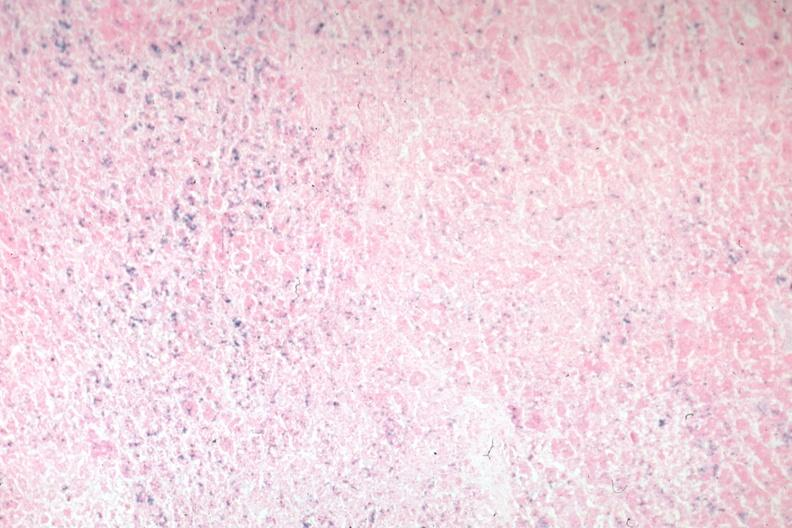s chromophobe adenoma present?
Answer the question using a single word or phrase. No 